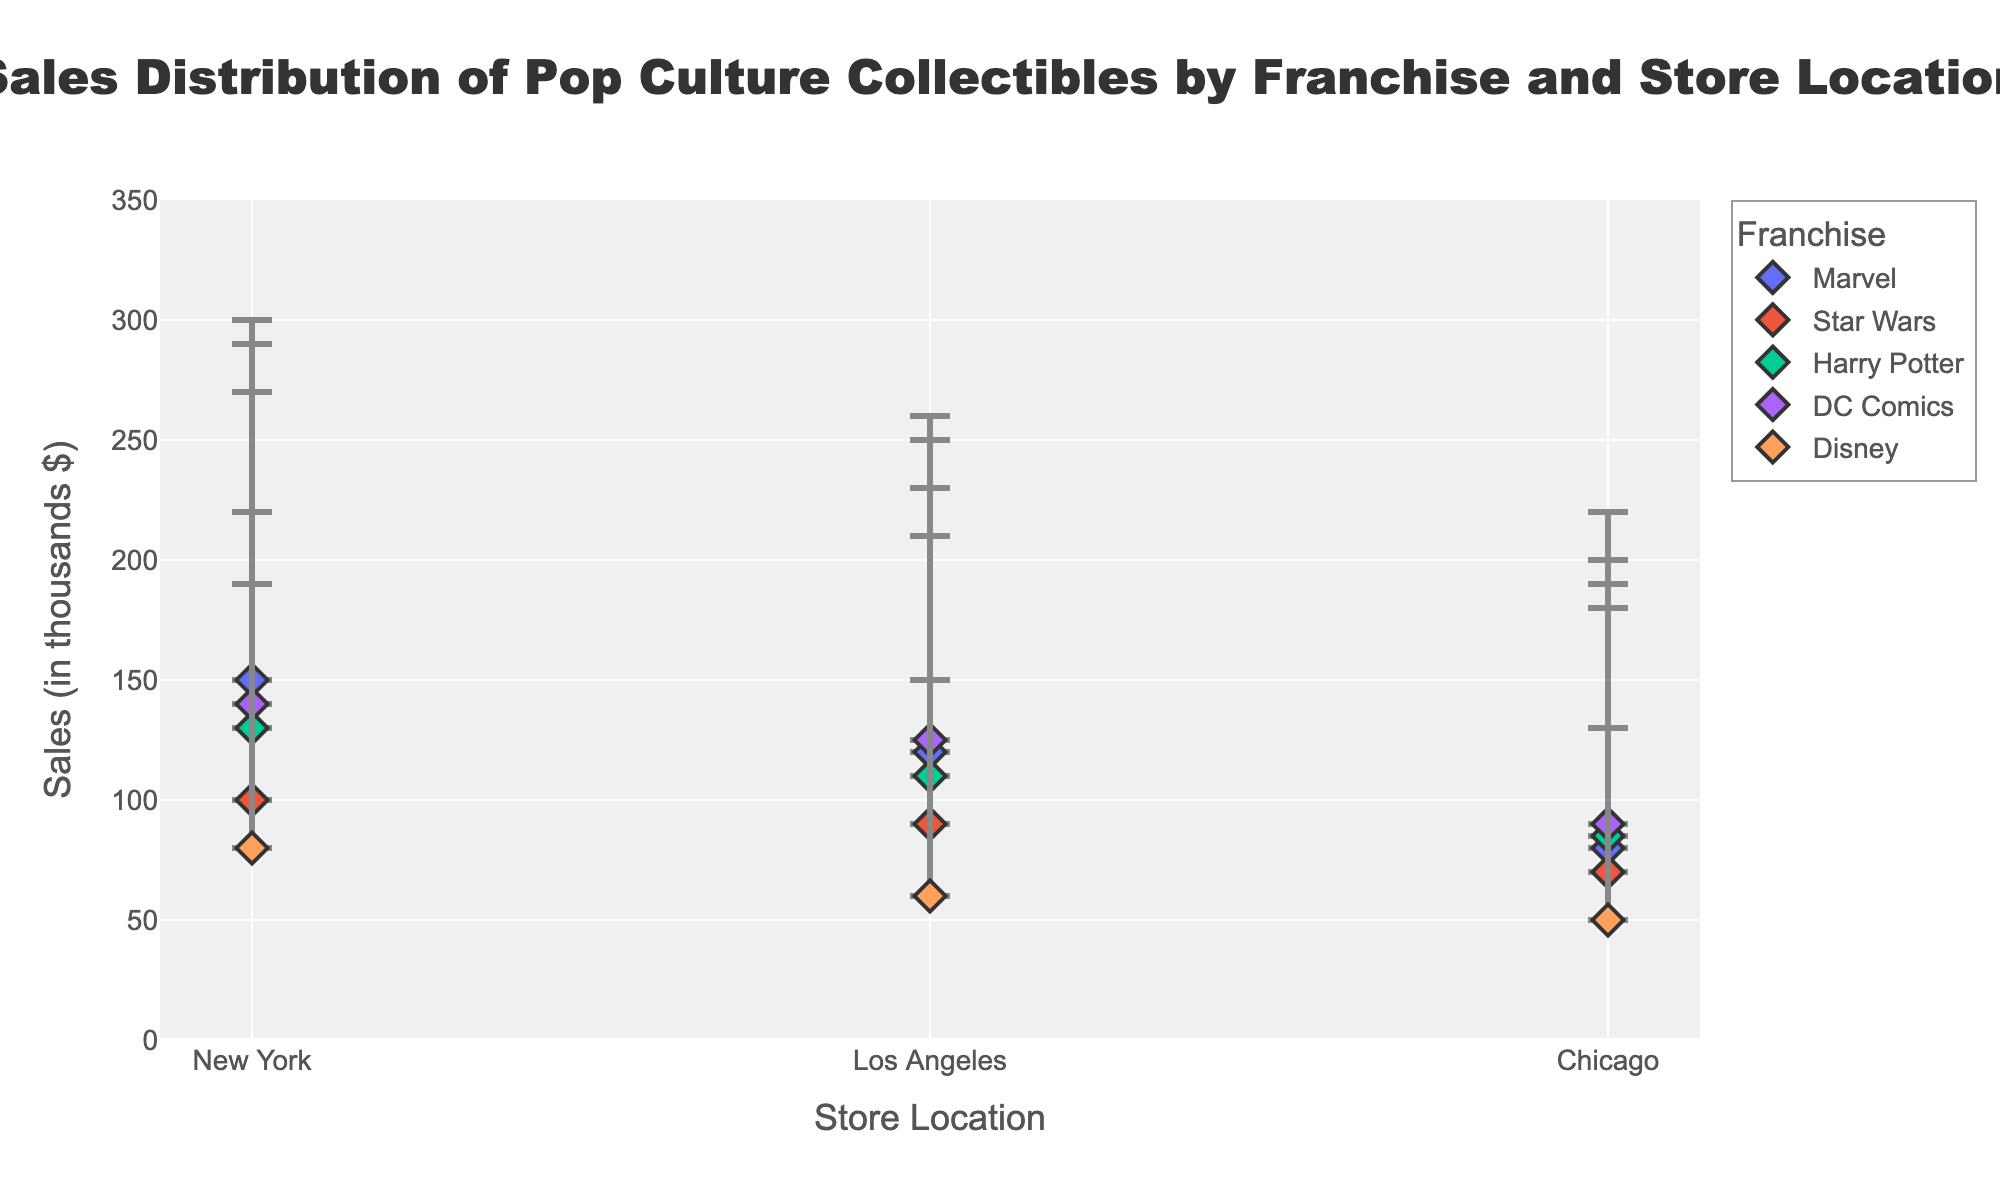In which store location does Marvel have the highest maximum sales? By looking at the endpoints of the range for Marvel across all locations, New York has a maximum sales value of 300, which is higher than the maximum sales in Los Angeles (250) and Chicago (200).
Answer: New York What is the lowest minimum sales value among all franchises and store locations? By examining all the plotted minimum sales data points, Disney in Chicago has the lowest minimum sales value of 50.
Answer: 50 Between Star Wars in Los Angeles and Harry Potter in New York, which has a higher range of sales? The sales range for Star Wars in Los Angeles is 90 to 210, giving a range of 120. For Harry Potter in New York, the range is 130 to 270, giving a range of 140.
Answer: Harry Potter in New York What are the minimum and maximum sales values for DC Comics in Chicago? From the plot, the minimum sales value for DC Comics in Chicago is 90 and the maximum sales value is 220.
Answer: 90 and 220 Which franchise in New York has the lowest minimum sales value, and what is it? By comparing the minimum sales values of all franchises in New York, Disney has the lowest minimum sales value of 80.
Answer: Disney, 80 If you average the minimum sales values of Harry Potter across all store locations, what is the result? Harry Potter has minimum sales values of 130 in New York, 110 in Los Angeles, and 85 in Chicago. The average is calculated as (130 + 110 + 85) / 3 = 108.33.
Answer: 108.33 Which store location has the widest range of sales for Disney, and what is the range? By comparing the sales ranges of Disney in all store locations: New York (80 to 190), Los Angeles (60 to 150), and Chicago (50 to 130), New York has the widest range at 110.
Answer: New York, 110 How does the sales range of Marvel in Chicago compare to the sales range of DC Comics in Los Angeles? Marvel in Chicago has a sales range of 80 to 200, which is 120. DC Comics in Los Angeles has a range of 125 to 260, which is 135.
Answer: DC Comics in Los Angeles has a wider range Which franchise has the smallest difference between its minimum and maximum sales in New York, and what is the difference? By comparing the sales ranges of each franchise in New York: Marvel (150 to 300, range = 150), Star Wars (100 to 220, range = 120), Harry Potter (130 to 270, range = 140), DC Comics (140 to 290, range = 150), and Disney (80 to 190, range = 110), Disney has the smallest range of 110.
Answer: Disney, 110 What is the relationship between the maximum sales values for Marvel in New York and Harry Potter in Los Angeles? From the plot, the maximum sales value for Marvel in New York is 300, and for Harry Potter in Los Angeles, it is 230. Hence, Marvel in New York has a greater maximum sales value.
Answer: Marvel in New York has a greater maximum sales value 